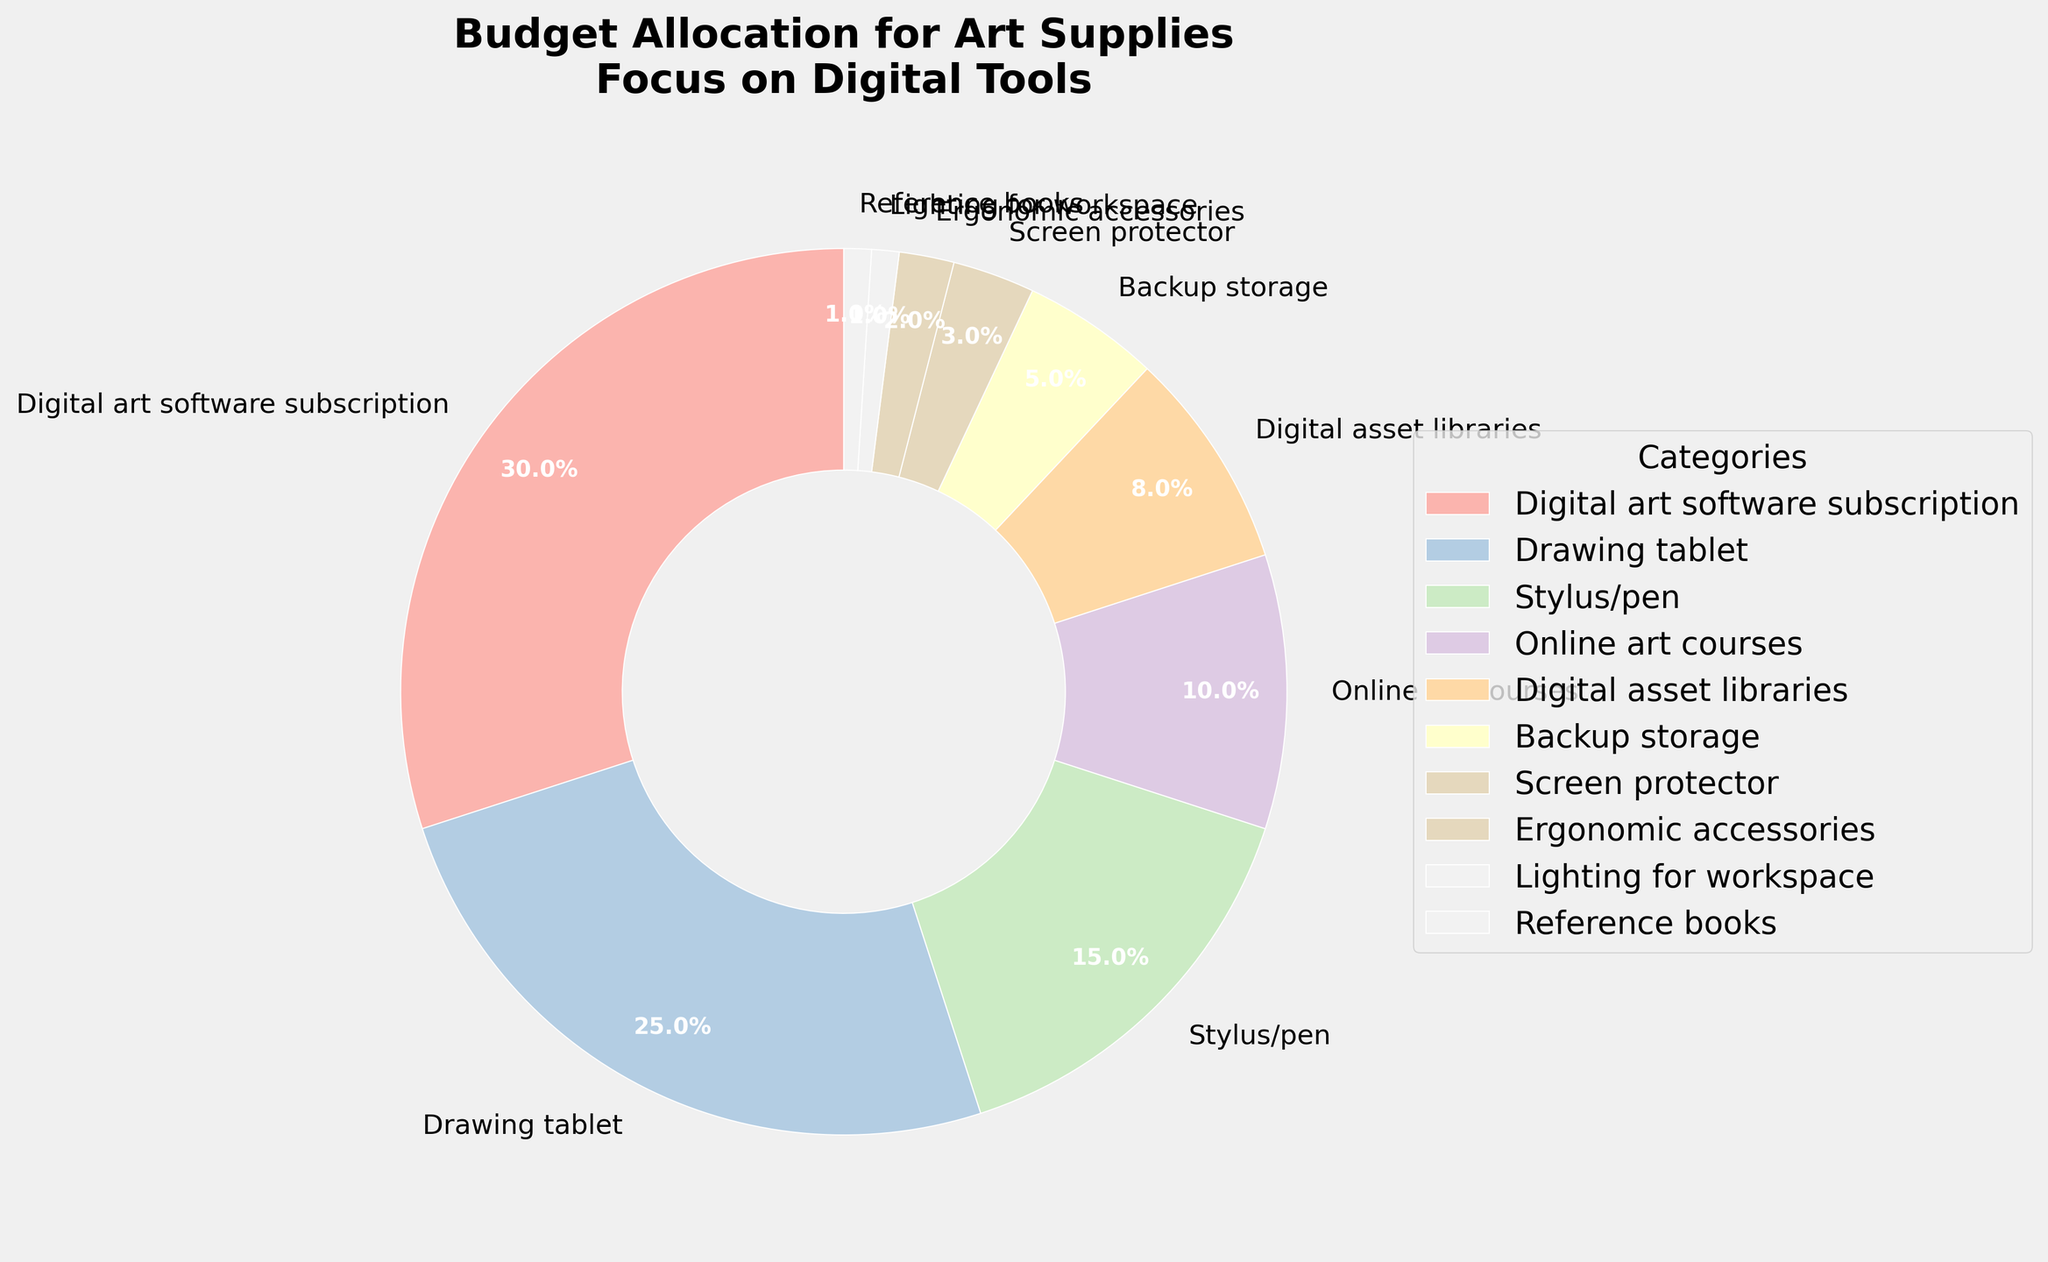What percentage of the budget is allocated to items other than the drawing tablet and stylus/pen combined? To find this, first add the percentages for the drawing tablet and stylus/pen: 25% (drawing tablet) + 15% (stylus/pen) = 40%. Subtract this from 100% to get the remaining percentage: 100% - 40% = 60%
Answer: 60% Which category has the smallest budget allocation? Look for the category with the lowest percentage in the pie chart. The reference books and lighting for workspace both have the smallest allocation at 1% each, but since we only need one, we can pick any.
Answer: Reference books Compare the budget allocation for digital asset libraries and backup storage. Which one has the higher allocation and by how much? Digital asset libraries have 8% and backup storage has 5%. The difference is 8% - 5% = 3%, and digital asset libraries have the higher allocation.
Answer: Digital asset libraries by 3% What is the total budget allocation for ergonomic accessories and lighting for the workspace combined? Add the percentages for ergonomic accessories and lighting for the workspace: 2% + 1% = 3%
Answer: 3% How does the budget allocated to digital art software subscriptions compare to the budget for online art courses? Digital art software subscriptions have 30% allocated, while online art courses have 10%. Therefore, the budget for digital art software subscriptions is 3 times the budget for online art courses.
Answer: 3 times Which category has the second-largest budget allocation, and what is its percentage? Look at the pie chart and find the category with the second-largest slice after digital art software subscriptions (30%). The drawing tablet is next with 25%.
Answer: Drawing tablet, 25% How much more budget is allocated to digital art software subscriptions compared to stylus/pen? Digital art software subscriptions have 30% and the stylus/pen has 15%. The difference is 30% - 15% = 15%
Answer: 15% Which three categories have the smallest allocations, and what are their combined percentages? Look for the categories with the smallest slices in the pie chart: Reference books (1%), Lighting for workspace (1%), and Ergonomic accessories (2%). Their combined percentage is 1% + 1% + 2% = 4%
Answer: 4% By visually inspecting the pie chart, what can you infer about the balanced distribution of the budget? Are the budget allocations mostly leaning towards a few categories, or are they evenly distributed? The pie chart shows that the bulk of the budget is allocated to digital art software subscriptions (30%) and the drawing tablet (25%), which together make up more than half the budget. Other categories have much smaller allocations, indicating that the budget is heavily skewed towards a few items.
Answer: Skewed towards a few categories 